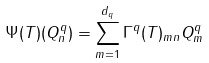<formula> <loc_0><loc_0><loc_500><loc_500>\Psi ( T ) ( Q ^ { q } _ { n } ) = \sum _ { m = 1 } ^ { d _ { q } } \Gamma ^ { q } ( T ) _ { m n } Q ^ { q } _ { m }</formula> 